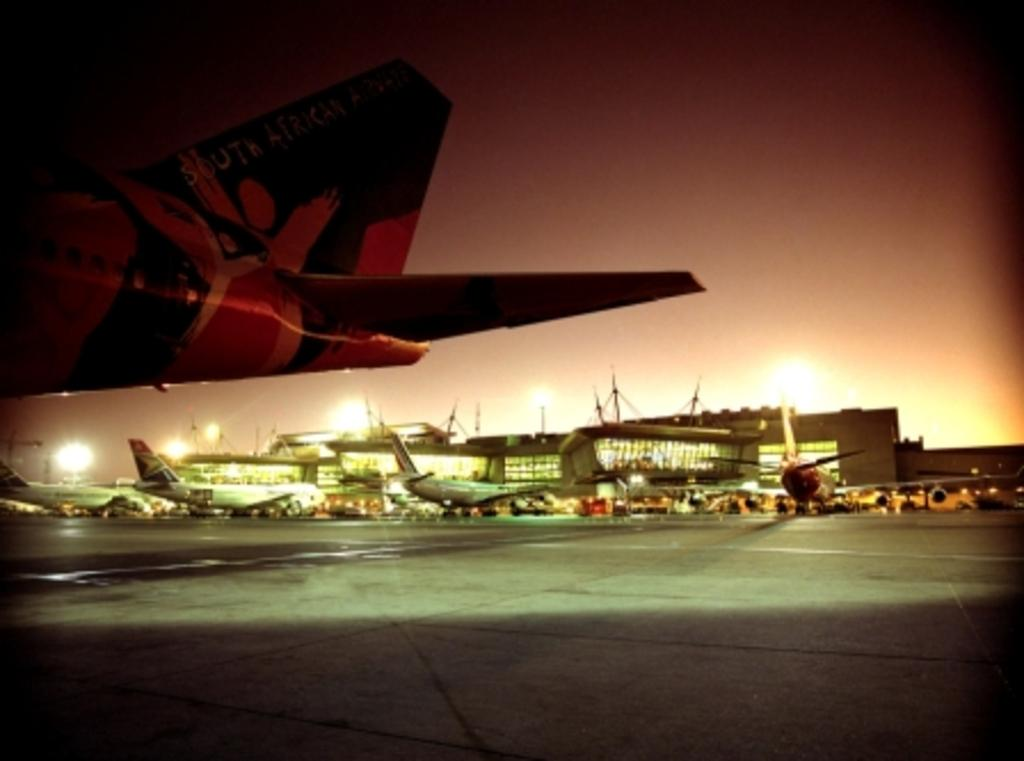What is the main subject of the image? The main subject of the image is airplanes. What else can be seen in the image besides airplanes? There are buildings visible in the image. What can be seen in the background of the image? Lights and the sky are visible in the background of the image. Can you tell me how many yaks are grazing in the background of the image? There are no yaks present in the image; it features airplanes and buildings. What type of letters can be seen on the airplanes in the image? There is no information about letters on the airplanes in the provided facts, so we cannot answer that question. 